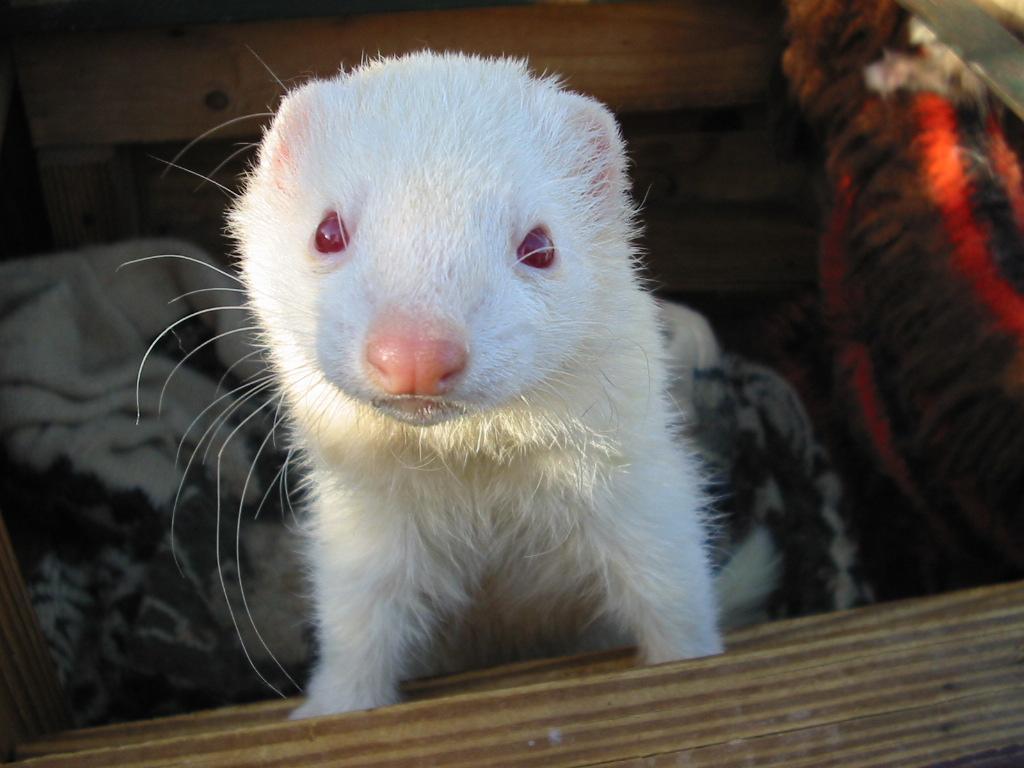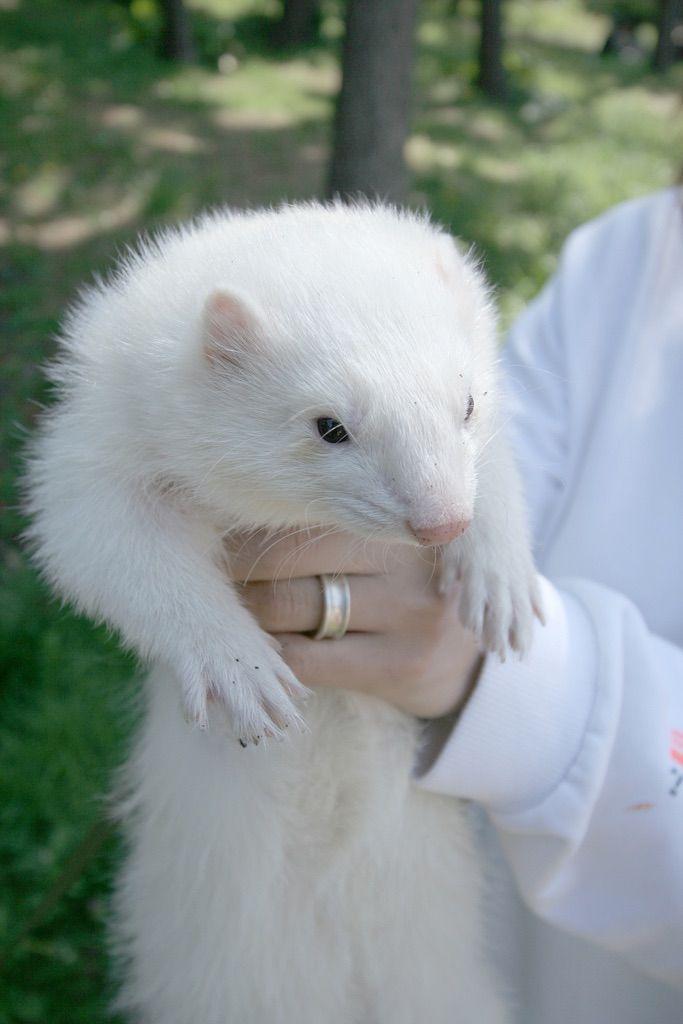The first image is the image on the left, the second image is the image on the right. Given the left and right images, does the statement "A person is holding up the animal in one of the images." hold true? Answer yes or no. Yes. The first image is the image on the left, the second image is the image on the right. For the images shown, is this caption "a white ferret is being held in a human hand" true? Answer yes or no. Yes. 